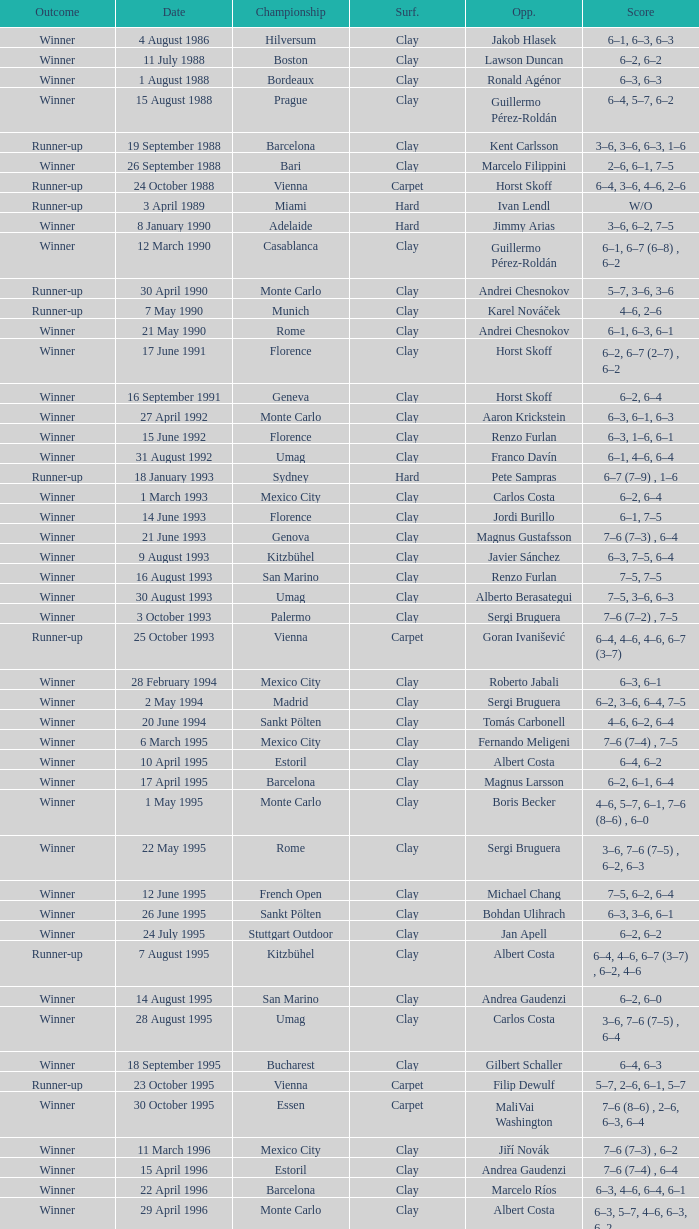Who is the opponent on 18 january 1993? Pete Sampras. 